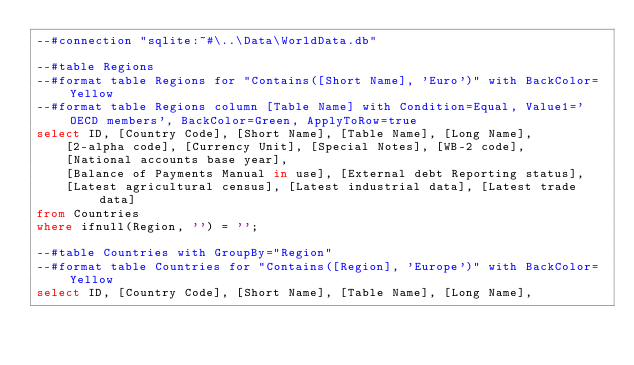<code> <loc_0><loc_0><loc_500><loc_500><_SQL_>--#connection "sqlite:~#\..\Data\WorldData.db"

--#table Regions
--#format table Regions for "Contains([Short Name], 'Euro')" with BackColor=Yellow
--#format table Regions column [Table Name] with Condition=Equal, Value1='OECD members', BackColor=Green, ApplyToRow=true
select ID, [Country Code], [Short Name], [Table Name], [Long Name],
	[2-alpha code], [Currency Unit], [Special Notes], [WB-2 code], 
	[National accounts base year],
	[Balance of Payments Manual in use], [External debt Reporting status],
	[Latest agricultural census], [Latest industrial data], [Latest trade data]
from Countries
where ifnull(Region, '') = '';

--#table Countries with GroupBy="Region"
--#format table Countries for "Contains([Region], 'Europe')" with BackColor=Yellow
select ID, [Country Code], [Short Name], [Table Name], [Long Name],</code> 